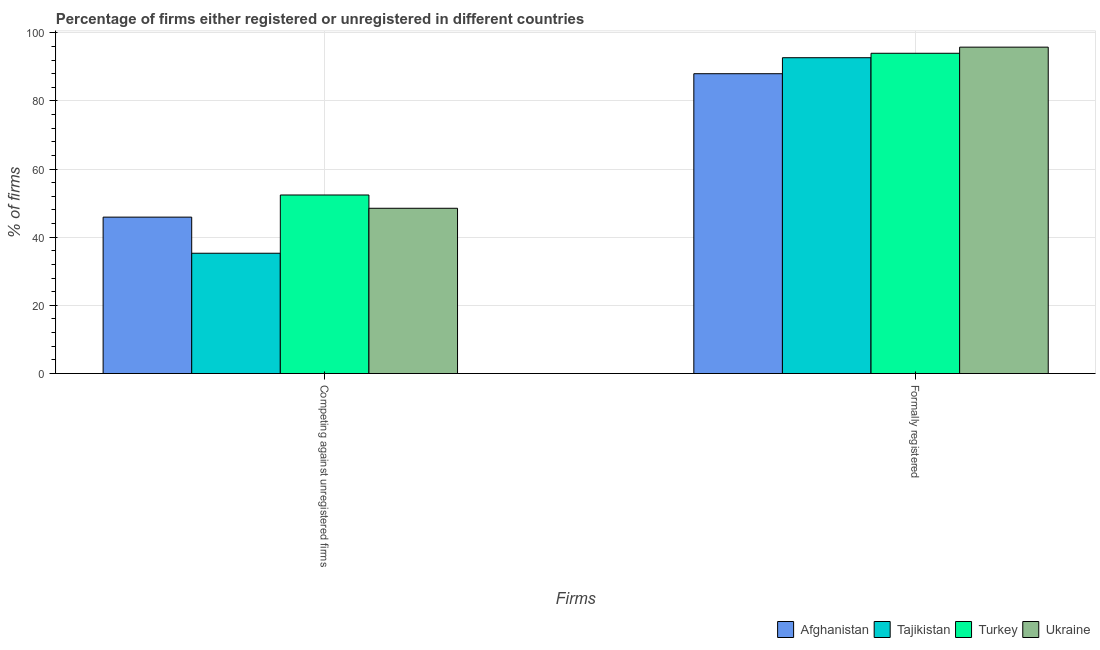How many different coloured bars are there?
Your answer should be very brief. 4. How many groups of bars are there?
Keep it short and to the point. 2. Are the number of bars on each tick of the X-axis equal?
Offer a very short reply. Yes. How many bars are there on the 2nd tick from the right?
Offer a very short reply. 4. What is the label of the 2nd group of bars from the left?
Your answer should be compact. Formally registered. What is the percentage of formally registered firms in Ukraine?
Your answer should be very brief. 95.8. Across all countries, what is the maximum percentage of registered firms?
Your response must be concise. 52.4. In which country was the percentage of formally registered firms maximum?
Your response must be concise. Ukraine. In which country was the percentage of formally registered firms minimum?
Offer a terse response. Afghanistan. What is the total percentage of formally registered firms in the graph?
Your answer should be compact. 370.5. What is the difference between the percentage of formally registered firms in Tajikistan and the percentage of registered firms in Ukraine?
Ensure brevity in your answer.  44.2. What is the average percentage of registered firms per country?
Offer a terse response. 45.52. What is the difference between the percentage of registered firms and percentage of formally registered firms in Tajikistan?
Your answer should be very brief. -57.4. What is the ratio of the percentage of formally registered firms in Turkey to that in Afghanistan?
Your response must be concise. 1.07. What does the 1st bar from the left in Formally registered represents?
Your answer should be very brief. Afghanistan. What does the 4th bar from the right in Competing against unregistered firms represents?
Make the answer very short. Afghanistan. Are all the bars in the graph horizontal?
Your response must be concise. No. Does the graph contain grids?
Provide a succinct answer. Yes. Where does the legend appear in the graph?
Your answer should be compact. Bottom right. How many legend labels are there?
Your response must be concise. 4. How are the legend labels stacked?
Make the answer very short. Horizontal. What is the title of the graph?
Your response must be concise. Percentage of firms either registered or unregistered in different countries. What is the label or title of the X-axis?
Provide a succinct answer. Firms. What is the label or title of the Y-axis?
Provide a succinct answer. % of firms. What is the % of firms in Afghanistan in Competing against unregistered firms?
Provide a short and direct response. 45.9. What is the % of firms in Tajikistan in Competing against unregistered firms?
Your response must be concise. 35.3. What is the % of firms in Turkey in Competing against unregistered firms?
Ensure brevity in your answer.  52.4. What is the % of firms of Ukraine in Competing against unregistered firms?
Your answer should be very brief. 48.5. What is the % of firms of Tajikistan in Formally registered?
Ensure brevity in your answer.  92.7. What is the % of firms of Turkey in Formally registered?
Ensure brevity in your answer.  94. What is the % of firms of Ukraine in Formally registered?
Ensure brevity in your answer.  95.8. Across all Firms, what is the maximum % of firms in Afghanistan?
Provide a short and direct response. 88. Across all Firms, what is the maximum % of firms of Tajikistan?
Provide a short and direct response. 92.7. Across all Firms, what is the maximum % of firms of Turkey?
Provide a short and direct response. 94. Across all Firms, what is the maximum % of firms of Ukraine?
Your answer should be compact. 95.8. Across all Firms, what is the minimum % of firms in Afghanistan?
Provide a succinct answer. 45.9. Across all Firms, what is the minimum % of firms of Tajikistan?
Ensure brevity in your answer.  35.3. Across all Firms, what is the minimum % of firms of Turkey?
Your answer should be compact. 52.4. Across all Firms, what is the minimum % of firms in Ukraine?
Your answer should be very brief. 48.5. What is the total % of firms in Afghanistan in the graph?
Offer a terse response. 133.9. What is the total % of firms in Tajikistan in the graph?
Your answer should be compact. 128. What is the total % of firms of Turkey in the graph?
Keep it short and to the point. 146.4. What is the total % of firms in Ukraine in the graph?
Your response must be concise. 144.3. What is the difference between the % of firms of Afghanistan in Competing against unregistered firms and that in Formally registered?
Make the answer very short. -42.1. What is the difference between the % of firms in Tajikistan in Competing against unregistered firms and that in Formally registered?
Offer a very short reply. -57.4. What is the difference between the % of firms of Turkey in Competing against unregistered firms and that in Formally registered?
Your answer should be compact. -41.6. What is the difference between the % of firms of Ukraine in Competing against unregistered firms and that in Formally registered?
Your response must be concise. -47.3. What is the difference between the % of firms in Afghanistan in Competing against unregistered firms and the % of firms in Tajikistan in Formally registered?
Ensure brevity in your answer.  -46.8. What is the difference between the % of firms in Afghanistan in Competing against unregistered firms and the % of firms in Turkey in Formally registered?
Offer a very short reply. -48.1. What is the difference between the % of firms of Afghanistan in Competing against unregistered firms and the % of firms of Ukraine in Formally registered?
Offer a terse response. -49.9. What is the difference between the % of firms in Tajikistan in Competing against unregistered firms and the % of firms in Turkey in Formally registered?
Give a very brief answer. -58.7. What is the difference between the % of firms of Tajikistan in Competing against unregistered firms and the % of firms of Ukraine in Formally registered?
Ensure brevity in your answer.  -60.5. What is the difference between the % of firms in Turkey in Competing against unregistered firms and the % of firms in Ukraine in Formally registered?
Offer a very short reply. -43.4. What is the average % of firms of Afghanistan per Firms?
Offer a terse response. 66.95. What is the average % of firms in Tajikistan per Firms?
Offer a terse response. 64. What is the average % of firms in Turkey per Firms?
Your response must be concise. 73.2. What is the average % of firms in Ukraine per Firms?
Ensure brevity in your answer.  72.15. What is the difference between the % of firms of Afghanistan and % of firms of Tajikistan in Competing against unregistered firms?
Your response must be concise. 10.6. What is the difference between the % of firms of Afghanistan and % of firms of Turkey in Competing against unregistered firms?
Your answer should be compact. -6.5. What is the difference between the % of firms of Tajikistan and % of firms of Turkey in Competing against unregistered firms?
Ensure brevity in your answer.  -17.1. What is the difference between the % of firms in Tajikistan and % of firms in Ukraine in Competing against unregistered firms?
Ensure brevity in your answer.  -13.2. What is the difference between the % of firms in Afghanistan and % of firms in Tajikistan in Formally registered?
Give a very brief answer. -4.7. What is the difference between the % of firms of Afghanistan and % of firms of Ukraine in Formally registered?
Give a very brief answer. -7.8. What is the difference between the % of firms of Tajikistan and % of firms of Turkey in Formally registered?
Offer a very short reply. -1.3. What is the difference between the % of firms of Turkey and % of firms of Ukraine in Formally registered?
Provide a succinct answer. -1.8. What is the ratio of the % of firms of Afghanistan in Competing against unregistered firms to that in Formally registered?
Provide a short and direct response. 0.52. What is the ratio of the % of firms in Tajikistan in Competing against unregistered firms to that in Formally registered?
Offer a terse response. 0.38. What is the ratio of the % of firms in Turkey in Competing against unregistered firms to that in Formally registered?
Your response must be concise. 0.56. What is the ratio of the % of firms in Ukraine in Competing against unregistered firms to that in Formally registered?
Give a very brief answer. 0.51. What is the difference between the highest and the second highest % of firms of Afghanistan?
Provide a short and direct response. 42.1. What is the difference between the highest and the second highest % of firms of Tajikistan?
Keep it short and to the point. 57.4. What is the difference between the highest and the second highest % of firms in Turkey?
Make the answer very short. 41.6. What is the difference between the highest and the second highest % of firms in Ukraine?
Make the answer very short. 47.3. What is the difference between the highest and the lowest % of firms in Afghanistan?
Offer a very short reply. 42.1. What is the difference between the highest and the lowest % of firms of Tajikistan?
Make the answer very short. 57.4. What is the difference between the highest and the lowest % of firms of Turkey?
Ensure brevity in your answer.  41.6. What is the difference between the highest and the lowest % of firms of Ukraine?
Make the answer very short. 47.3. 